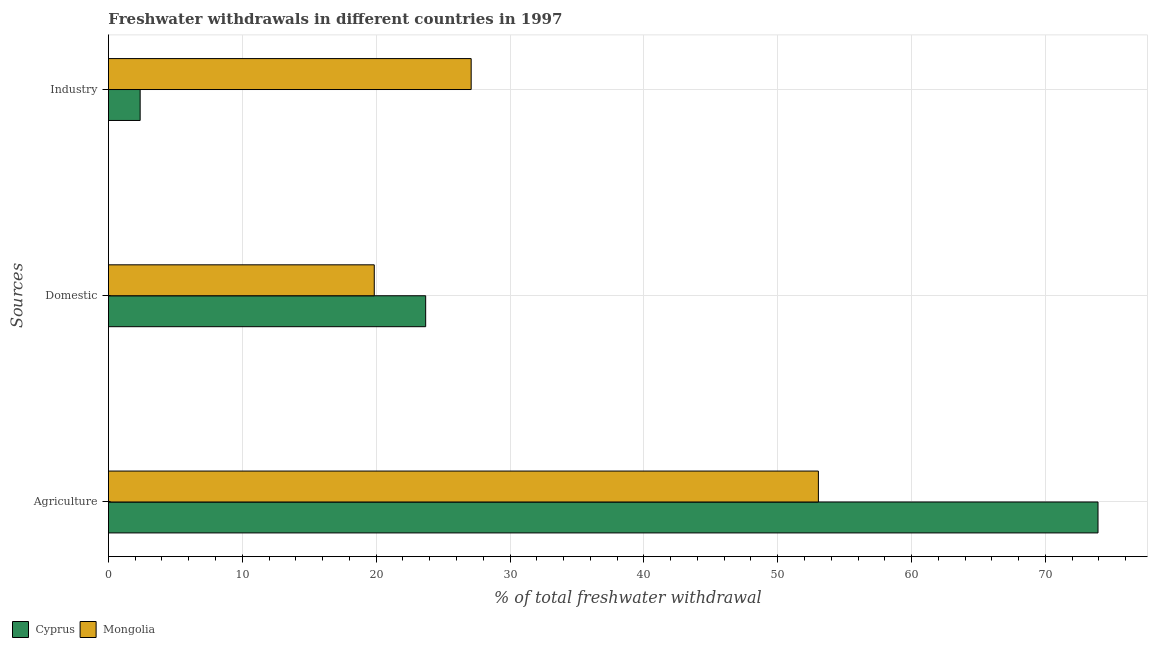Are the number of bars per tick equal to the number of legend labels?
Make the answer very short. Yes. How many bars are there on the 1st tick from the top?
Ensure brevity in your answer.  2. How many bars are there on the 3rd tick from the bottom?
Your response must be concise. 2. What is the label of the 2nd group of bars from the top?
Offer a terse response. Domestic. What is the percentage of freshwater withdrawal for industry in Cyprus?
Give a very brief answer. 2.37. Across all countries, what is the maximum percentage of freshwater withdrawal for domestic purposes?
Ensure brevity in your answer.  23.7. Across all countries, what is the minimum percentage of freshwater withdrawal for domestic purposes?
Provide a succinct answer. 19.86. In which country was the percentage of freshwater withdrawal for industry maximum?
Provide a short and direct response. Mongolia. In which country was the percentage of freshwater withdrawal for agriculture minimum?
Offer a terse response. Mongolia. What is the total percentage of freshwater withdrawal for industry in the graph?
Offer a terse response. 29.47. What is the difference between the percentage of freshwater withdrawal for agriculture in Mongolia and that in Cyprus?
Make the answer very short. -20.89. What is the difference between the percentage of freshwater withdrawal for industry in Mongolia and the percentage of freshwater withdrawal for domestic purposes in Cyprus?
Offer a very short reply. 3.4. What is the average percentage of freshwater withdrawal for domestic purposes per country?
Offer a very short reply. 21.78. What is the difference between the percentage of freshwater withdrawal for domestic purposes and percentage of freshwater withdrawal for industry in Mongolia?
Offer a very short reply. -7.24. In how many countries, is the percentage of freshwater withdrawal for domestic purposes greater than 28 %?
Your answer should be compact. 0. What is the ratio of the percentage of freshwater withdrawal for agriculture in Mongolia to that in Cyprus?
Offer a terse response. 0.72. Is the percentage of freshwater withdrawal for industry in Cyprus less than that in Mongolia?
Offer a terse response. Yes. What is the difference between the highest and the second highest percentage of freshwater withdrawal for agriculture?
Give a very brief answer. 20.89. What is the difference between the highest and the lowest percentage of freshwater withdrawal for industry?
Provide a short and direct response. 24.73. In how many countries, is the percentage of freshwater withdrawal for domestic purposes greater than the average percentage of freshwater withdrawal for domestic purposes taken over all countries?
Ensure brevity in your answer.  1. What does the 2nd bar from the top in Domestic represents?
Give a very brief answer. Cyprus. What does the 1st bar from the bottom in Domestic represents?
Your answer should be very brief. Cyprus. What is the difference between two consecutive major ticks on the X-axis?
Give a very brief answer. 10. Are the values on the major ticks of X-axis written in scientific E-notation?
Make the answer very short. No. Does the graph contain any zero values?
Ensure brevity in your answer.  No. Where does the legend appear in the graph?
Your response must be concise. Bottom left. How are the legend labels stacked?
Provide a short and direct response. Horizontal. What is the title of the graph?
Keep it short and to the point. Freshwater withdrawals in different countries in 1997. Does "Mali" appear as one of the legend labels in the graph?
Offer a very short reply. No. What is the label or title of the X-axis?
Provide a short and direct response. % of total freshwater withdrawal. What is the label or title of the Y-axis?
Give a very brief answer. Sources. What is the % of total freshwater withdrawal of Cyprus in Agriculture?
Your answer should be very brief. 73.93. What is the % of total freshwater withdrawal in Mongolia in Agriculture?
Your answer should be compact. 53.04. What is the % of total freshwater withdrawal in Cyprus in Domestic?
Provide a succinct answer. 23.7. What is the % of total freshwater withdrawal of Mongolia in Domestic?
Your answer should be compact. 19.86. What is the % of total freshwater withdrawal in Cyprus in Industry?
Provide a short and direct response. 2.37. What is the % of total freshwater withdrawal in Mongolia in Industry?
Make the answer very short. 27.1. Across all Sources, what is the maximum % of total freshwater withdrawal in Cyprus?
Provide a succinct answer. 73.93. Across all Sources, what is the maximum % of total freshwater withdrawal in Mongolia?
Provide a short and direct response. 53.04. Across all Sources, what is the minimum % of total freshwater withdrawal of Cyprus?
Make the answer very short. 2.37. Across all Sources, what is the minimum % of total freshwater withdrawal of Mongolia?
Make the answer very short. 19.86. What is the total % of total freshwater withdrawal of Mongolia in the graph?
Provide a succinct answer. 100. What is the difference between the % of total freshwater withdrawal in Cyprus in Agriculture and that in Domestic?
Provide a succinct answer. 50.23. What is the difference between the % of total freshwater withdrawal in Mongolia in Agriculture and that in Domestic?
Offer a very short reply. 33.18. What is the difference between the % of total freshwater withdrawal of Cyprus in Agriculture and that in Industry?
Provide a succinct answer. 71.56. What is the difference between the % of total freshwater withdrawal in Mongolia in Agriculture and that in Industry?
Your response must be concise. 25.94. What is the difference between the % of total freshwater withdrawal of Cyprus in Domestic and that in Industry?
Ensure brevity in your answer.  21.33. What is the difference between the % of total freshwater withdrawal in Mongolia in Domestic and that in Industry?
Offer a terse response. -7.24. What is the difference between the % of total freshwater withdrawal of Cyprus in Agriculture and the % of total freshwater withdrawal of Mongolia in Domestic?
Keep it short and to the point. 54.07. What is the difference between the % of total freshwater withdrawal of Cyprus in Agriculture and the % of total freshwater withdrawal of Mongolia in Industry?
Your response must be concise. 46.83. What is the difference between the % of total freshwater withdrawal of Cyprus in Domestic and the % of total freshwater withdrawal of Mongolia in Industry?
Make the answer very short. -3.4. What is the average % of total freshwater withdrawal in Cyprus per Sources?
Your response must be concise. 33.33. What is the average % of total freshwater withdrawal of Mongolia per Sources?
Your answer should be very brief. 33.33. What is the difference between the % of total freshwater withdrawal in Cyprus and % of total freshwater withdrawal in Mongolia in Agriculture?
Provide a succinct answer. 20.89. What is the difference between the % of total freshwater withdrawal in Cyprus and % of total freshwater withdrawal in Mongolia in Domestic?
Your answer should be compact. 3.84. What is the difference between the % of total freshwater withdrawal in Cyprus and % of total freshwater withdrawal in Mongolia in Industry?
Make the answer very short. -24.73. What is the ratio of the % of total freshwater withdrawal of Cyprus in Agriculture to that in Domestic?
Your response must be concise. 3.12. What is the ratio of the % of total freshwater withdrawal of Mongolia in Agriculture to that in Domestic?
Make the answer very short. 2.67. What is the ratio of the % of total freshwater withdrawal of Cyprus in Agriculture to that in Industry?
Your answer should be very brief. 31.19. What is the ratio of the % of total freshwater withdrawal in Mongolia in Agriculture to that in Industry?
Make the answer very short. 1.96. What is the ratio of the % of total freshwater withdrawal in Cyprus in Domestic to that in Industry?
Ensure brevity in your answer.  10. What is the ratio of the % of total freshwater withdrawal of Mongolia in Domestic to that in Industry?
Make the answer very short. 0.73. What is the difference between the highest and the second highest % of total freshwater withdrawal in Cyprus?
Give a very brief answer. 50.23. What is the difference between the highest and the second highest % of total freshwater withdrawal in Mongolia?
Keep it short and to the point. 25.94. What is the difference between the highest and the lowest % of total freshwater withdrawal of Cyprus?
Provide a succinct answer. 71.56. What is the difference between the highest and the lowest % of total freshwater withdrawal of Mongolia?
Ensure brevity in your answer.  33.18. 